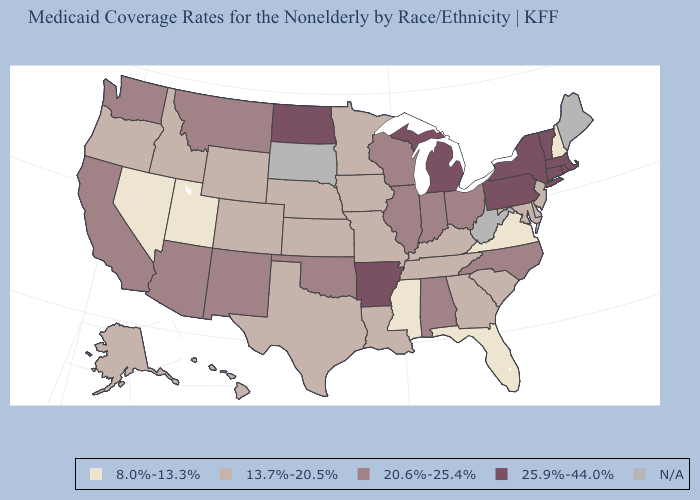Name the states that have a value in the range 13.7%-20.5%?
Short answer required. Alaska, Colorado, Delaware, Georgia, Hawaii, Idaho, Iowa, Kansas, Kentucky, Louisiana, Maryland, Minnesota, Missouri, Nebraska, New Jersey, Oregon, South Carolina, Tennessee, Texas, Wyoming. What is the lowest value in states that border Michigan?
Be succinct. 20.6%-25.4%. What is the value of Virginia?
Short answer required. 8.0%-13.3%. What is the value of Alaska?
Keep it brief. 13.7%-20.5%. What is the lowest value in the Northeast?
Give a very brief answer. 8.0%-13.3%. Does the first symbol in the legend represent the smallest category?
Keep it brief. Yes. What is the lowest value in states that border Georgia?
Short answer required. 8.0%-13.3%. Which states have the lowest value in the MidWest?
Concise answer only. Iowa, Kansas, Minnesota, Missouri, Nebraska. How many symbols are there in the legend?
Write a very short answer. 5. Is the legend a continuous bar?
Give a very brief answer. No. Is the legend a continuous bar?
Answer briefly. No. Name the states that have a value in the range N/A?
Be succinct. Maine, South Dakota, West Virginia. What is the value of Missouri?
Be succinct. 13.7%-20.5%. Name the states that have a value in the range 8.0%-13.3%?
Answer briefly. Florida, Mississippi, Nevada, New Hampshire, Utah, Virginia. 